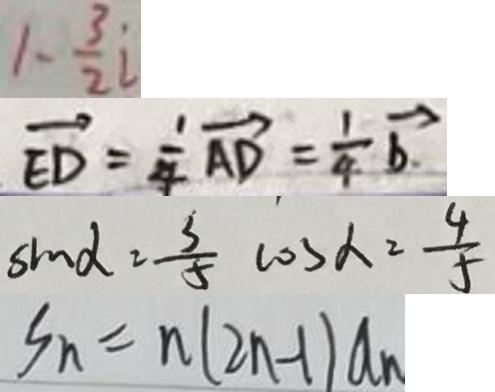Convert formula to latex. <formula><loc_0><loc_0><loc_500><loc_500>1 - \frac { 3 } { 2 } i 
 \overrightarrow { E D } = \frac { 1 } { 4 } \overrightarrow { A D } = \frac { 1 } { 4 } \overrightarrow { b } . 
 \sin \alpha = \frac { 3 } { 5 } \cos \alpha = \frac { 4 } { 5 } 
 S _ { n } = n ( 2 n - 1 ) a _ { n }</formula> 